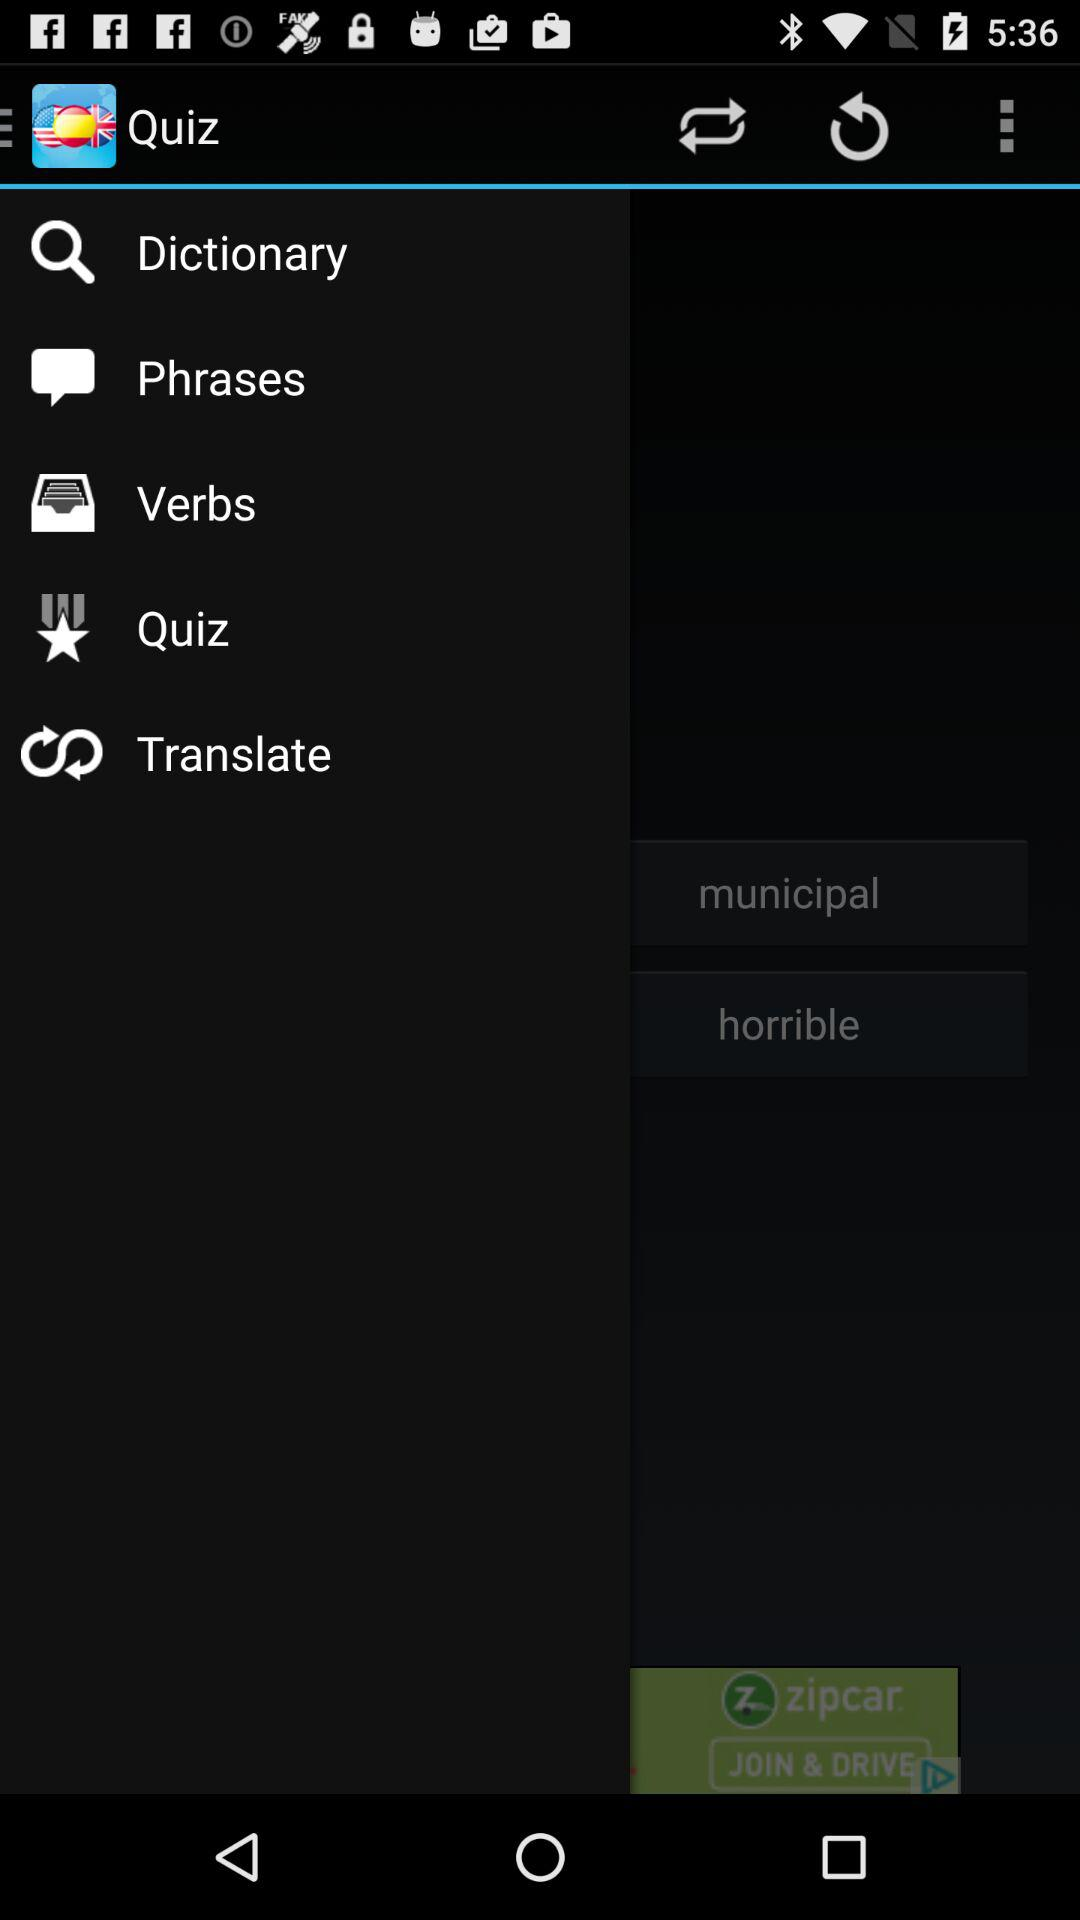What is the name of the application? The application name is "Quiz". 